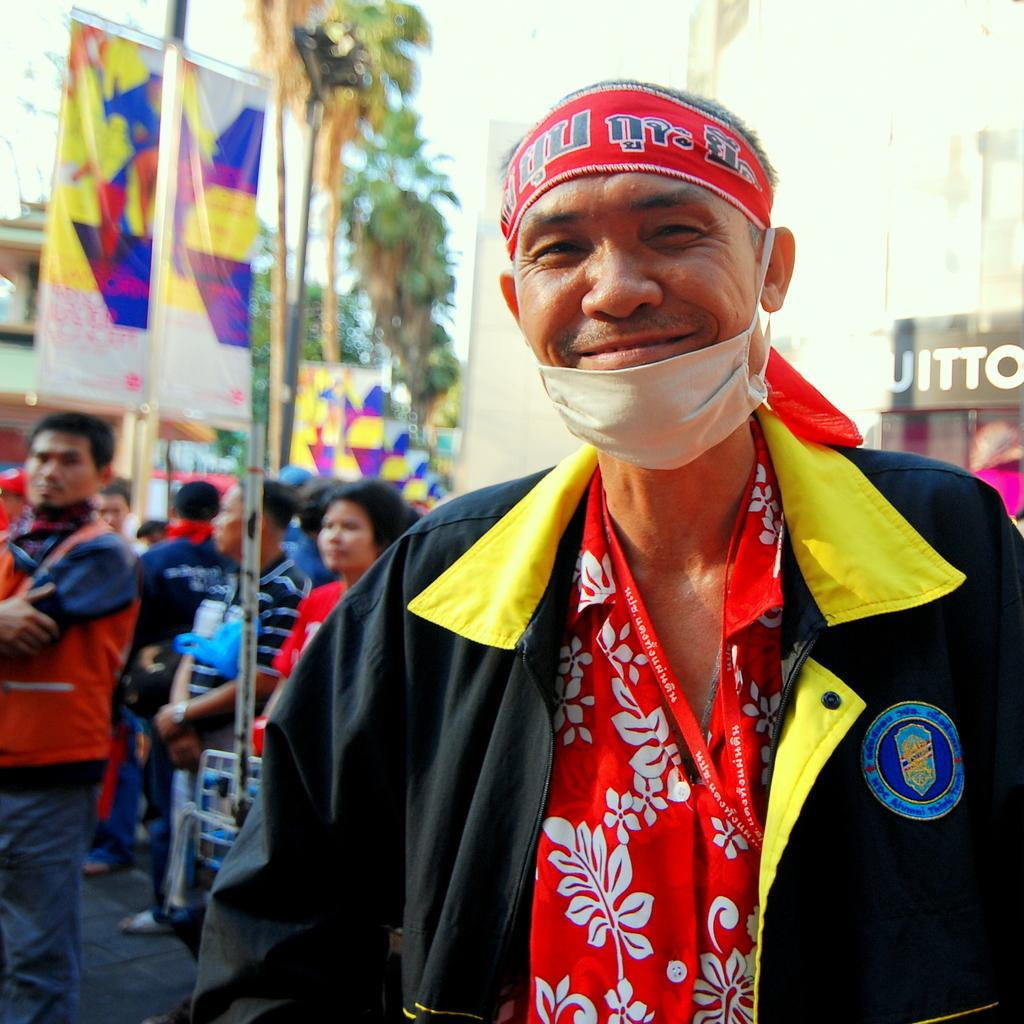What is the main subject of the image? The main subject of the image is a group of people standing. What can be seen in the background of the image? There are trees, banners, and buildings visible in the background of the image. What type of advertisement can be seen on the tree in the image? There is no advertisement present on a tree in the image. 